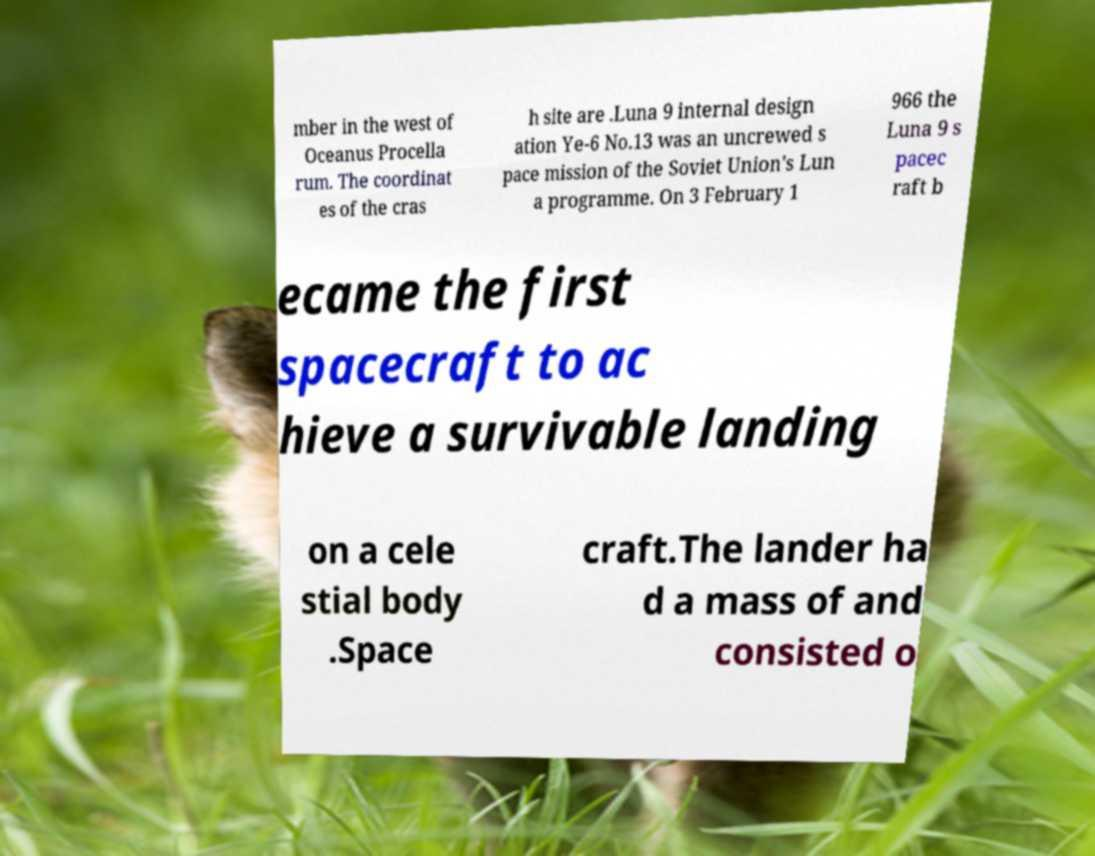There's text embedded in this image that I need extracted. Can you transcribe it verbatim? mber in the west of Oceanus Procella rum. The coordinat es of the cras h site are .Luna 9 internal design ation Ye-6 No.13 was an uncrewed s pace mission of the Soviet Union's Lun a programme. On 3 February 1 966 the Luna 9 s pacec raft b ecame the first spacecraft to ac hieve a survivable landing on a cele stial body .Space craft.The lander ha d a mass of and consisted o 